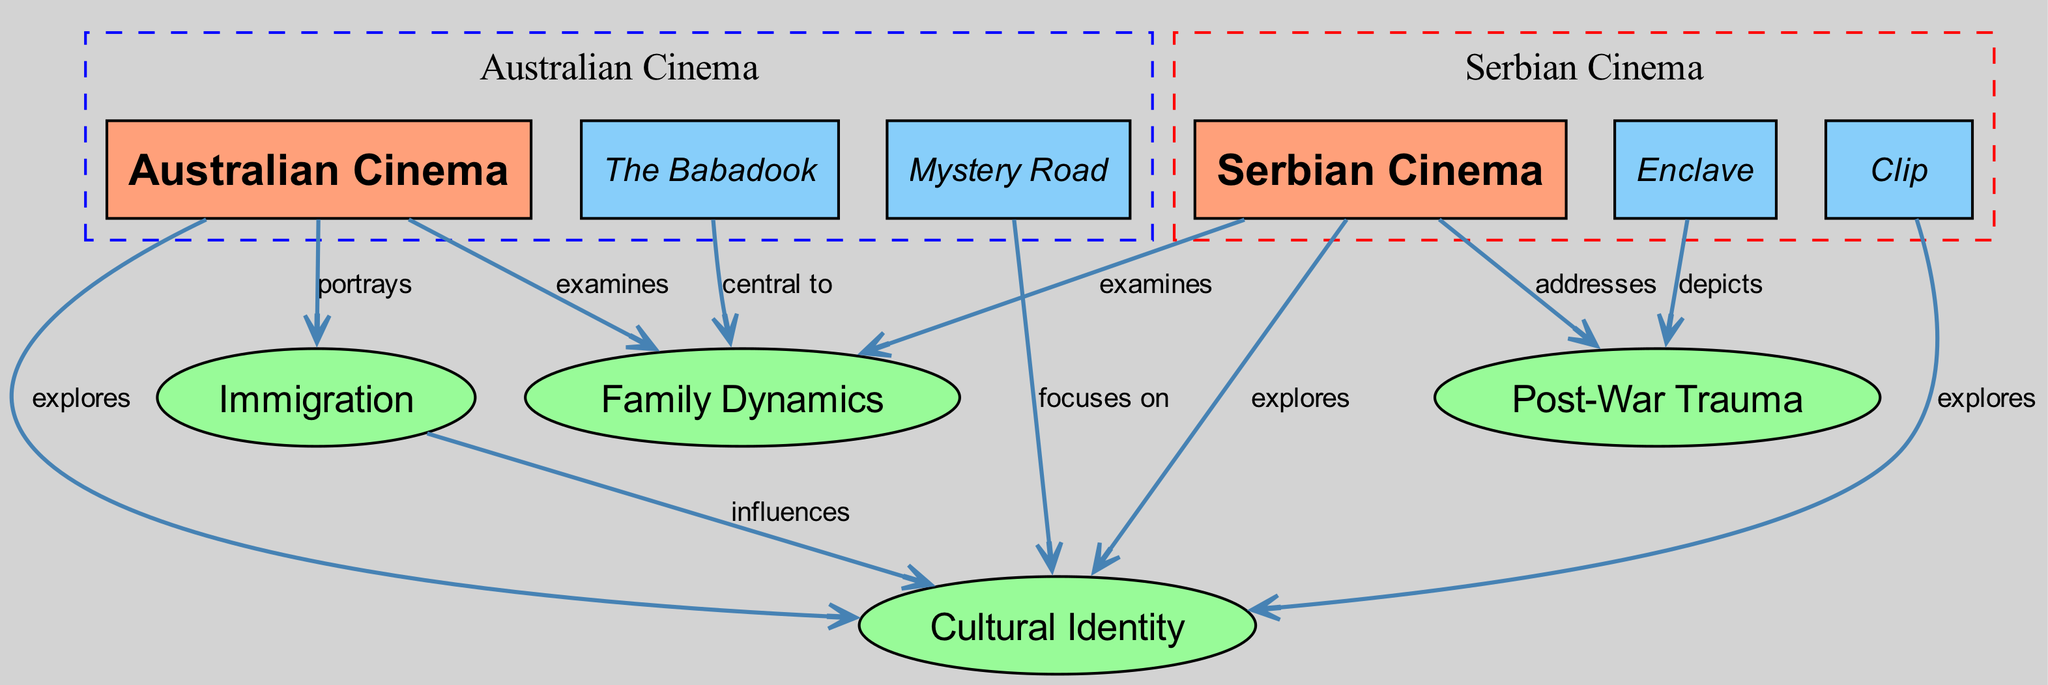What are the main cinemas represented in the diagram? The diagram identifies two main cinemas, "Australian Cinema" and "Serbian Cinema," which are both central nodes. These are clearly labeled as main categories in the diagram.
Answer: Australian Cinema, Serbian Cinema How many themes are interconnected with Australian Cinema? By tracing the edges from "Australian Cinema," we can see that it is connected to three themes: "Cultural Identity," "Immigration," and "Family Dynamics." Thus, there are three connections that illustrate interconnectedness.
Answer: 3 Which films are central to Family Dynamics in Australian Cinema? The diagram specifies that the film "The Babadook" is marked as "central to" "Family Dynamics," indicating its prominent role in exploring this theme within Australian Cinema.
Answer: The Babadook What is the relationship between Serbian Cinema and Post-War Trauma? The diagram shows a directed edge from "Serbian Cinema" to "Post-War Trauma," with the label "addresses," suggesting that Serbian Cinema actively reflects on or discusses this theme.
Answer: addresses Which theme is influenced by Immigration according to the diagram? The diagram indicates that "Immigration" influences "Cultural Identity." By following the directed edge labeled "influences," we can establish that this relationship exists.
Answer: Cultural Identity What types of films are represented in Serbian Cinema? Within the diagram, "Clip" and "Enclave" are categorized as films under "Serbian Cinema," showing their representation in the context of this cinema.
Answer: Clip, Enclave Which theme does the film "Mystery Road" focus on? According to the diagram, "Mystery Road" is connected to "Cultural Identity" through the edge labeled "focuses on," indicating that it addresses this particular theme.
Answer: Cultural Identity How many edges connect themes to Australian Cinema? Upon examining the connections from "Australian Cinema," there are four edges that lead to themes, which illustrates multiple interactions with thematic elements.
Answer: 4 Which film depicts Post-War Trauma according to the nodes? The diagram shows that "Enclave" is clearly linked to "Post-War Trauma" with an edge labeled "depicts," indicating its thematic content in relation to this subject.
Answer: Enclave 